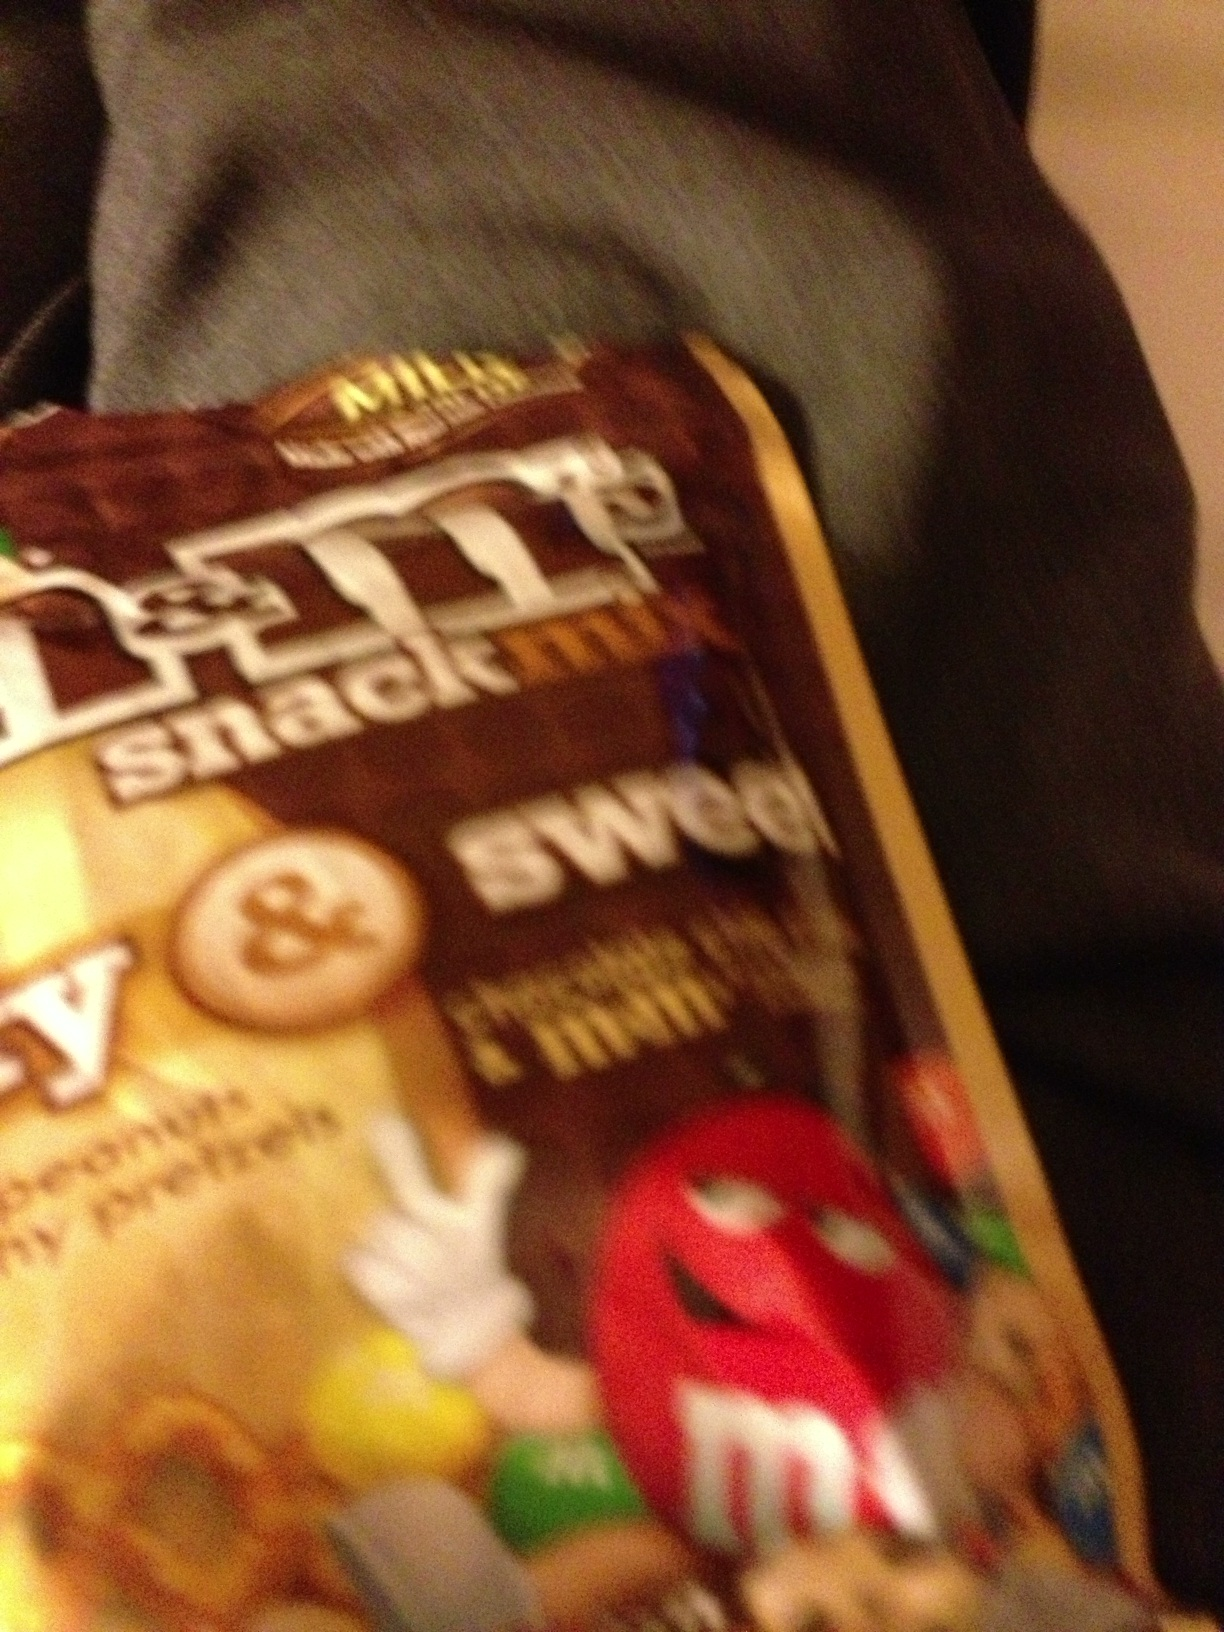Can you describe more about the types of snacks included in this M&Ms snack mix? The M&Ms snack mix typically includes a delightful combination of classic M&Ms chocolates, pretzels, and almonds. This mix combines the sweet chocolate flavor with the salty crunch of pretzels and the nutty taste of almonds, creating a varied snack experience. 